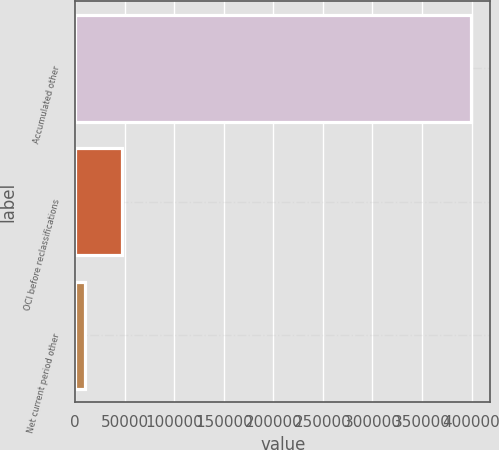Convert chart. <chart><loc_0><loc_0><loc_500><loc_500><bar_chart><fcel>Accumulated other<fcel>OCI before reclassifications<fcel>Net current period other<nl><fcel>399167<fcel>47244.7<fcel>10332<nl></chart> 